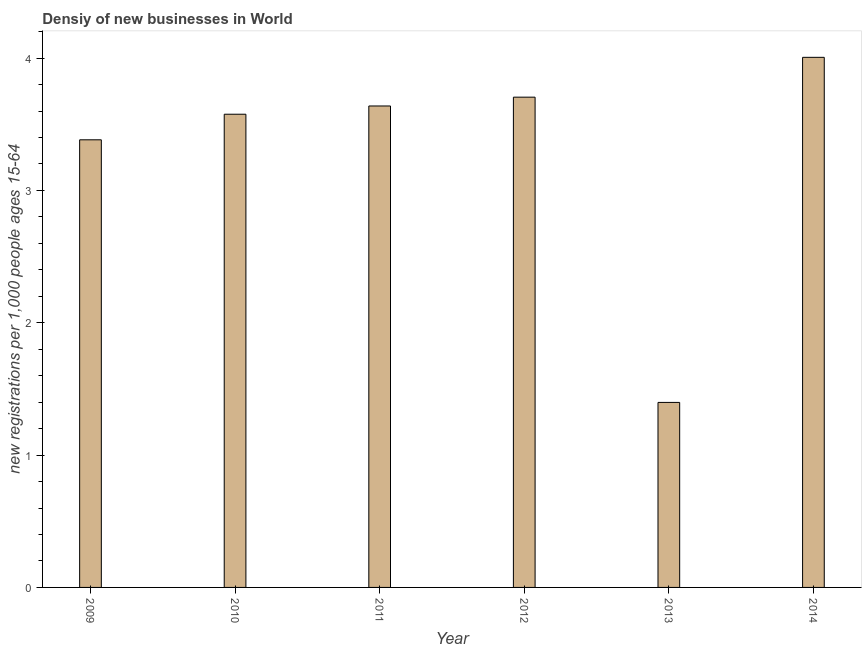What is the title of the graph?
Give a very brief answer. Densiy of new businesses in World. What is the label or title of the Y-axis?
Offer a terse response. New registrations per 1,0 people ages 15-64. What is the density of new business in 2009?
Your answer should be very brief. 3.38. Across all years, what is the maximum density of new business?
Ensure brevity in your answer.  4.01. Across all years, what is the minimum density of new business?
Ensure brevity in your answer.  1.4. In which year was the density of new business maximum?
Provide a succinct answer. 2014. In which year was the density of new business minimum?
Your answer should be compact. 2013. What is the sum of the density of new business?
Provide a short and direct response. 19.7. What is the difference between the density of new business in 2010 and 2011?
Make the answer very short. -0.06. What is the average density of new business per year?
Your answer should be compact. 3.28. What is the median density of new business?
Provide a short and direct response. 3.61. Do a majority of the years between 2011 and 2013 (inclusive) have density of new business greater than 3.6 ?
Your answer should be compact. Yes. What is the ratio of the density of new business in 2011 to that in 2014?
Offer a terse response. 0.91. Is the density of new business in 2010 less than that in 2012?
Keep it short and to the point. Yes. What is the difference between the highest and the second highest density of new business?
Make the answer very short. 0.3. Is the sum of the density of new business in 2012 and 2014 greater than the maximum density of new business across all years?
Offer a terse response. Yes. What is the difference between the highest and the lowest density of new business?
Ensure brevity in your answer.  2.61. In how many years, is the density of new business greater than the average density of new business taken over all years?
Ensure brevity in your answer.  5. How many bars are there?
Your answer should be compact. 6. Are the values on the major ticks of Y-axis written in scientific E-notation?
Your response must be concise. No. What is the new registrations per 1,000 people ages 15-64 of 2009?
Offer a terse response. 3.38. What is the new registrations per 1,000 people ages 15-64 in 2010?
Make the answer very short. 3.58. What is the new registrations per 1,000 people ages 15-64 in 2011?
Provide a succinct answer. 3.64. What is the new registrations per 1,000 people ages 15-64 in 2012?
Offer a terse response. 3.7. What is the new registrations per 1,000 people ages 15-64 in 2013?
Your answer should be compact. 1.4. What is the new registrations per 1,000 people ages 15-64 in 2014?
Provide a succinct answer. 4.01. What is the difference between the new registrations per 1,000 people ages 15-64 in 2009 and 2010?
Provide a short and direct response. -0.19. What is the difference between the new registrations per 1,000 people ages 15-64 in 2009 and 2011?
Make the answer very short. -0.26. What is the difference between the new registrations per 1,000 people ages 15-64 in 2009 and 2012?
Your response must be concise. -0.32. What is the difference between the new registrations per 1,000 people ages 15-64 in 2009 and 2013?
Your answer should be compact. 1.98. What is the difference between the new registrations per 1,000 people ages 15-64 in 2009 and 2014?
Offer a terse response. -0.62. What is the difference between the new registrations per 1,000 people ages 15-64 in 2010 and 2011?
Your answer should be compact. -0.06. What is the difference between the new registrations per 1,000 people ages 15-64 in 2010 and 2012?
Keep it short and to the point. -0.13. What is the difference between the new registrations per 1,000 people ages 15-64 in 2010 and 2013?
Offer a very short reply. 2.18. What is the difference between the new registrations per 1,000 people ages 15-64 in 2010 and 2014?
Give a very brief answer. -0.43. What is the difference between the new registrations per 1,000 people ages 15-64 in 2011 and 2012?
Your response must be concise. -0.07. What is the difference between the new registrations per 1,000 people ages 15-64 in 2011 and 2013?
Ensure brevity in your answer.  2.24. What is the difference between the new registrations per 1,000 people ages 15-64 in 2011 and 2014?
Make the answer very short. -0.37. What is the difference between the new registrations per 1,000 people ages 15-64 in 2012 and 2013?
Make the answer very short. 2.31. What is the difference between the new registrations per 1,000 people ages 15-64 in 2012 and 2014?
Your response must be concise. -0.3. What is the difference between the new registrations per 1,000 people ages 15-64 in 2013 and 2014?
Provide a succinct answer. -2.61. What is the ratio of the new registrations per 1,000 people ages 15-64 in 2009 to that in 2010?
Keep it short and to the point. 0.95. What is the ratio of the new registrations per 1,000 people ages 15-64 in 2009 to that in 2012?
Your response must be concise. 0.91. What is the ratio of the new registrations per 1,000 people ages 15-64 in 2009 to that in 2013?
Give a very brief answer. 2.42. What is the ratio of the new registrations per 1,000 people ages 15-64 in 2009 to that in 2014?
Your answer should be compact. 0.84. What is the ratio of the new registrations per 1,000 people ages 15-64 in 2010 to that in 2012?
Provide a succinct answer. 0.96. What is the ratio of the new registrations per 1,000 people ages 15-64 in 2010 to that in 2013?
Your answer should be very brief. 2.56. What is the ratio of the new registrations per 1,000 people ages 15-64 in 2010 to that in 2014?
Keep it short and to the point. 0.89. What is the ratio of the new registrations per 1,000 people ages 15-64 in 2011 to that in 2012?
Your answer should be compact. 0.98. What is the ratio of the new registrations per 1,000 people ages 15-64 in 2011 to that in 2013?
Give a very brief answer. 2.6. What is the ratio of the new registrations per 1,000 people ages 15-64 in 2011 to that in 2014?
Provide a succinct answer. 0.91. What is the ratio of the new registrations per 1,000 people ages 15-64 in 2012 to that in 2013?
Provide a short and direct response. 2.65. What is the ratio of the new registrations per 1,000 people ages 15-64 in 2012 to that in 2014?
Give a very brief answer. 0.93. What is the ratio of the new registrations per 1,000 people ages 15-64 in 2013 to that in 2014?
Your answer should be compact. 0.35. 